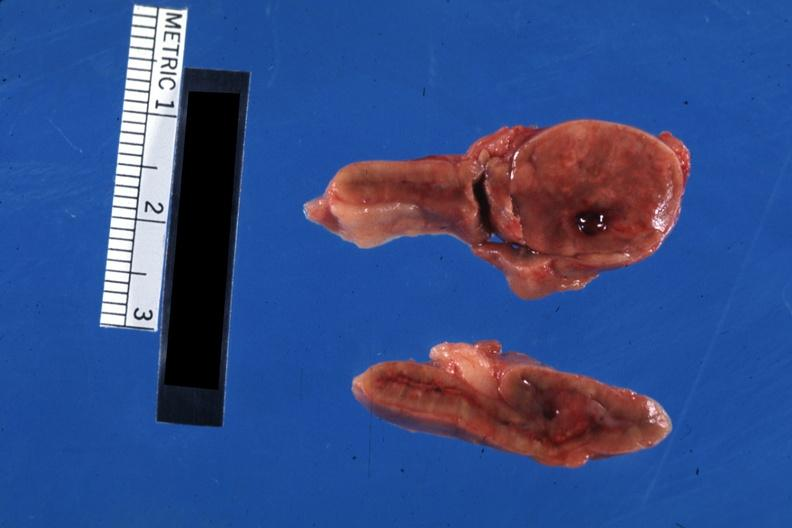what is present?
Answer the question using a single word or phrase. Adrenal 